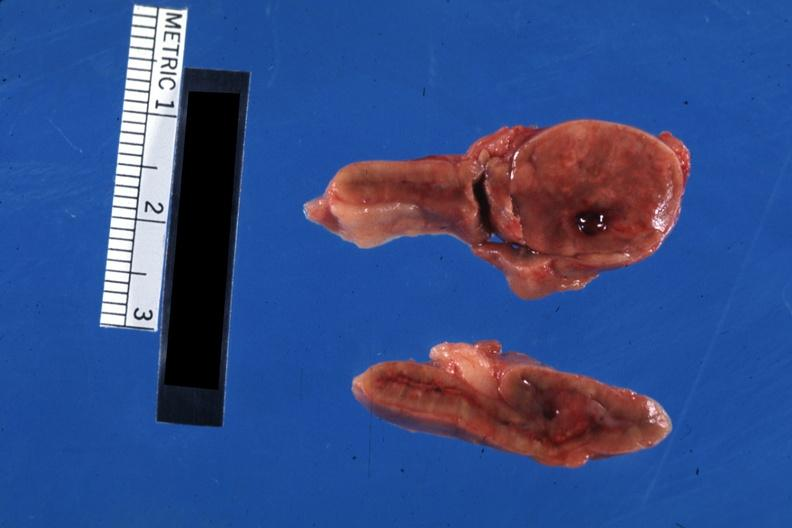what is present?
Answer the question using a single word or phrase. Adrenal 